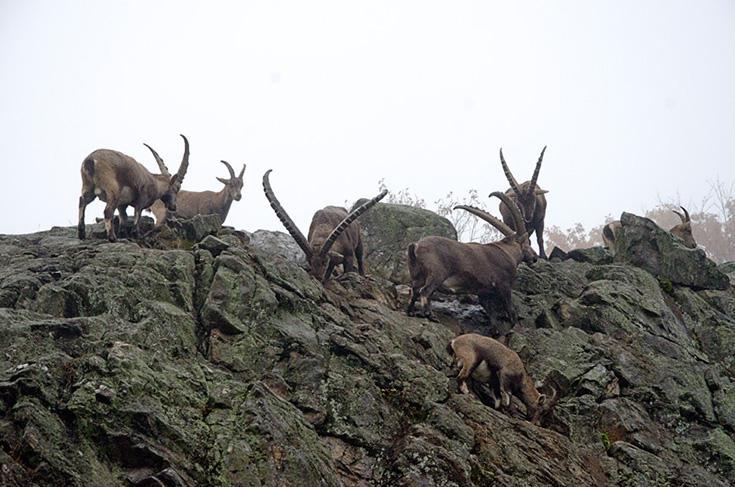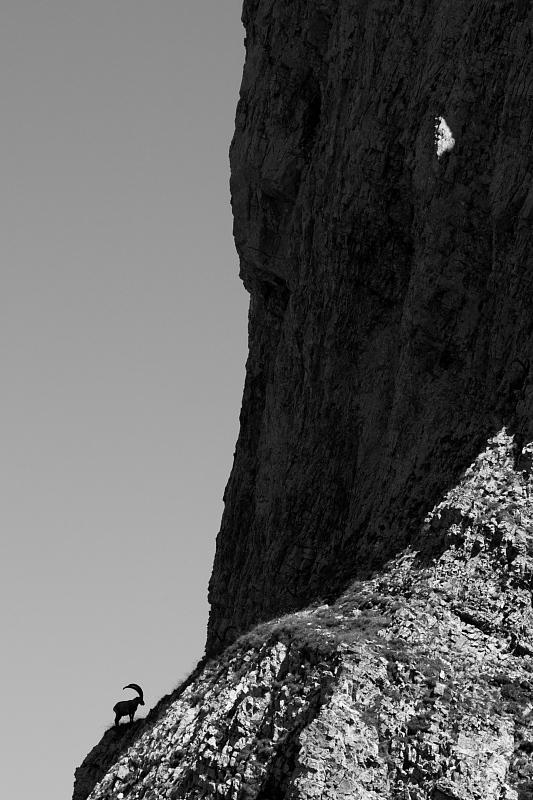The first image is the image on the left, the second image is the image on the right. Given the left and right images, does the statement "An image shows a ram with its head in profile, in a stark scene with no trees or green vegetation." hold true? Answer yes or no. Yes. The first image is the image on the left, the second image is the image on the right. Analyze the images presented: Is the assertion "There is a single animal standing in a rocky area in the image on the left." valid? Answer yes or no. No. 